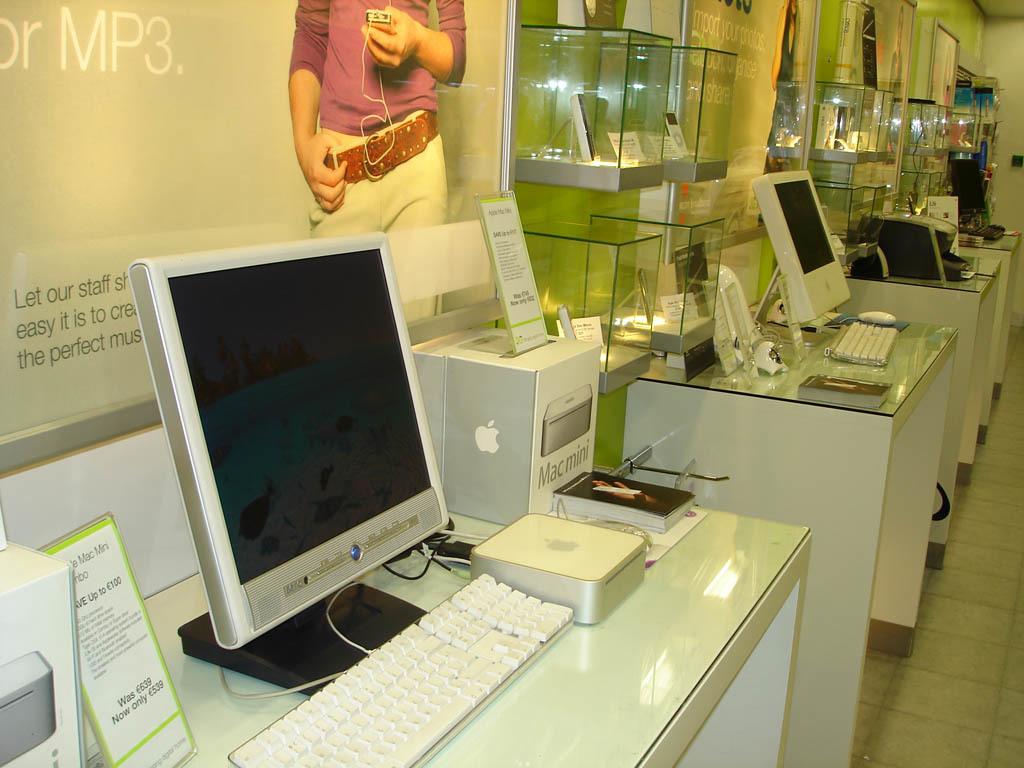What kind of computer is on display?
Give a very brief answer. Mac mini. What audio file format is shown behind the computer?
Offer a very short reply. Mp3. 